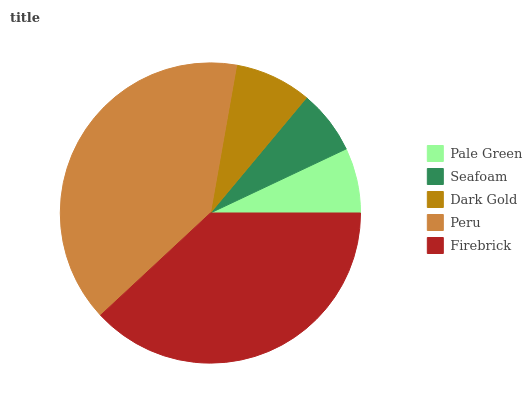Is Seafoam the minimum?
Answer yes or no. Yes. Is Peru the maximum?
Answer yes or no. Yes. Is Dark Gold the minimum?
Answer yes or no. No. Is Dark Gold the maximum?
Answer yes or no. No. Is Dark Gold greater than Seafoam?
Answer yes or no. Yes. Is Seafoam less than Dark Gold?
Answer yes or no. Yes. Is Seafoam greater than Dark Gold?
Answer yes or no. No. Is Dark Gold less than Seafoam?
Answer yes or no. No. Is Dark Gold the high median?
Answer yes or no. Yes. Is Dark Gold the low median?
Answer yes or no. Yes. Is Peru the high median?
Answer yes or no. No. Is Pale Green the low median?
Answer yes or no. No. 